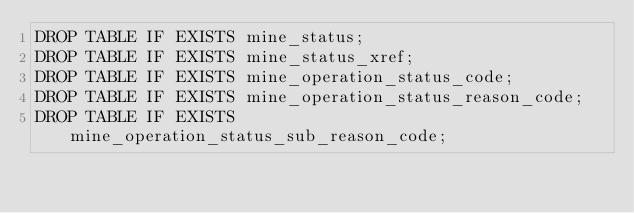Convert code to text. <code><loc_0><loc_0><loc_500><loc_500><_SQL_>DROP TABLE IF EXISTS mine_status;
DROP TABLE IF EXISTS mine_status_xref;
DROP TABLE IF EXISTS mine_operation_status_code;
DROP TABLE IF EXISTS mine_operation_status_reason_code;
DROP TABLE IF EXISTS mine_operation_status_sub_reason_code;
</code> 